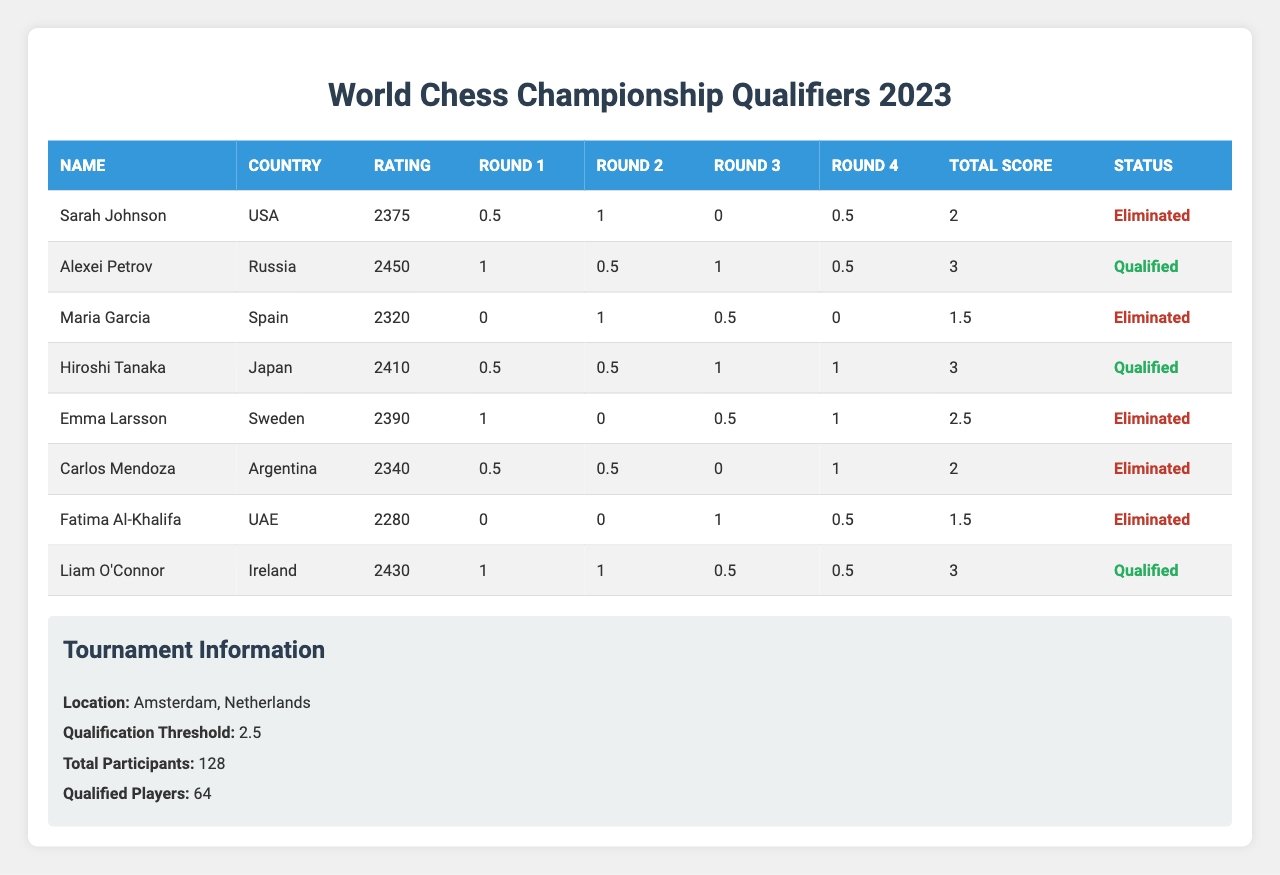What is the highest total score among the eliminated players? The eliminated players are Sarah Johnson, Maria Garcia, Emma Larsson, Carlos Mendoza, and Fatima Al-Khalifa. Their total scores are 2, 1.5, 2.5, 2, and 1.5, respectively. The highest score among them is 2.5 from Emma Larsson.
Answer: 2.5 Which player had the highest rating? The player with the highest rating is Alexei Petrov with a rating of 2450.
Answer: 2450 How many players were eliminated? There are 5 players marked as eliminated: Sarah Johnson, Maria Garcia, Emma Larsson, Carlos Mendoza, and Fatima Al-Khalifa.
Answer: 5 What is the average total score of the qualified players? The qualified players are Alexei Petrov, Hiroshi Tanaka, and Liam O'Connor, with total scores of 3, 3, and 3 respectively. The sum of their scores is 3 + 3 + 3 = 9, and there are 3 players, so the average score is 9 / 3 = 3.
Answer: 3 Did any player score a total of 1.5? Yes, Maria Garcia and Fatima Al-Khalifa both scored a total of 1.5.
Answer: Yes What is the total number of players who scored above the qualification threshold? The qualification threshold is 2.5. The players who scored above this are Alexei Petrov, Hiroshi Tanaka, and Liam O'Connor. Hence, 3 players scored above the threshold.
Answer: 3 Which player from the USA scored the least? Sarah Johnson is the only player from the USA, and she scored a total of 2 points, which is the least for her.
Answer: 2 What is the difference between the highest score and the qualification threshold? The highest total score among all players is 3 (from Alexei Petrov, Hiroshi Tanaka, and Liam O'Connor), and the qualification threshold is 2.5. The difference is 3 - 2.5 = 0.5.
Answer: 0.5 How many players scored a total score of 2? There are 3 players who scored a total score of 2: Sarah Johnson, Carlos Mendoza, and Liam O'Connor.
Answer: 3 Which country had the player with the highest qualification scores? The player with the highest qualification score is from Russia, Alexei Petrov, who scored a total of 3 points.
Answer: Russia 